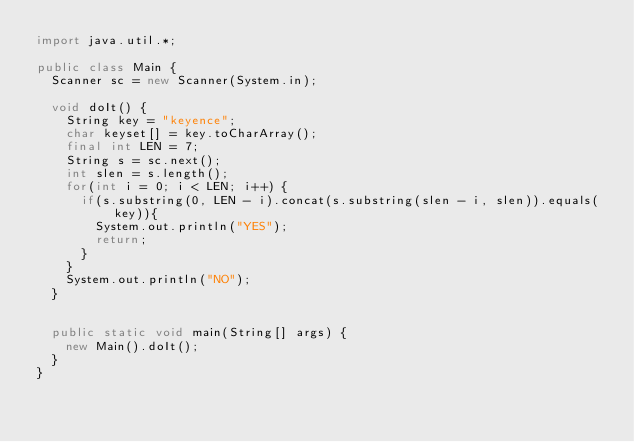Convert code to text. <code><loc_0><loc_0><loc_500><loc_500><_Java_>import java.util.*;

public class Main {
	Scanner sc = new Scanner(System.in);

	void doIt() {
		String key = "keyence"; 
		char keyset[] = key.toCharArray();
		final int LEN = 7;
		String s = sc.next();
		int slen = s.length();
		for(int i = 0; i < LEN; i++) {
			if(s.substring(0, LEN - i).concat(s.substring(slen - i, slen)).equals(key)){
				System.out.println("YES");
				return;
			}
		}
		System.out.println("NO");
	}


	public static void main(String[] args) {
		new Main().doIt();
	}
}
</code> 